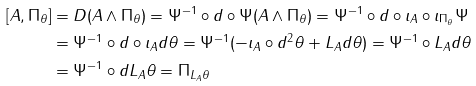Convert formula to latex. <formula><loc_0><loc_0><loc_500><loc_500>[ A , \Pi _ { \theta } ] & = D ( A \wedge \Pi _ { \theta } ) = \Psi ^ { - 1 } \circ d \circ \Psi ( A \wedge \Pi _ { \theta } ) = \Psi ^ { - 1 } \circ d \circ \imath _ { A } \circ \imath _ { \Pi _ { \theta } } \Psi \\ & = \Psi ^ { - 1 } \circ d \circ \imath _ { A } d \theta = \Psi ^ { - 1 } ( - \imath _ { A } \circ d ^ { 2 } \theta + L _ { A } d \theta ) = \Psi ^ { - 1 } \circ L _ { A } d \theta \\ & = \Psi ^ { - 1 } \circ d L _ { A } \theta = \Pi _ { L _ { A } \theta }</formula> 